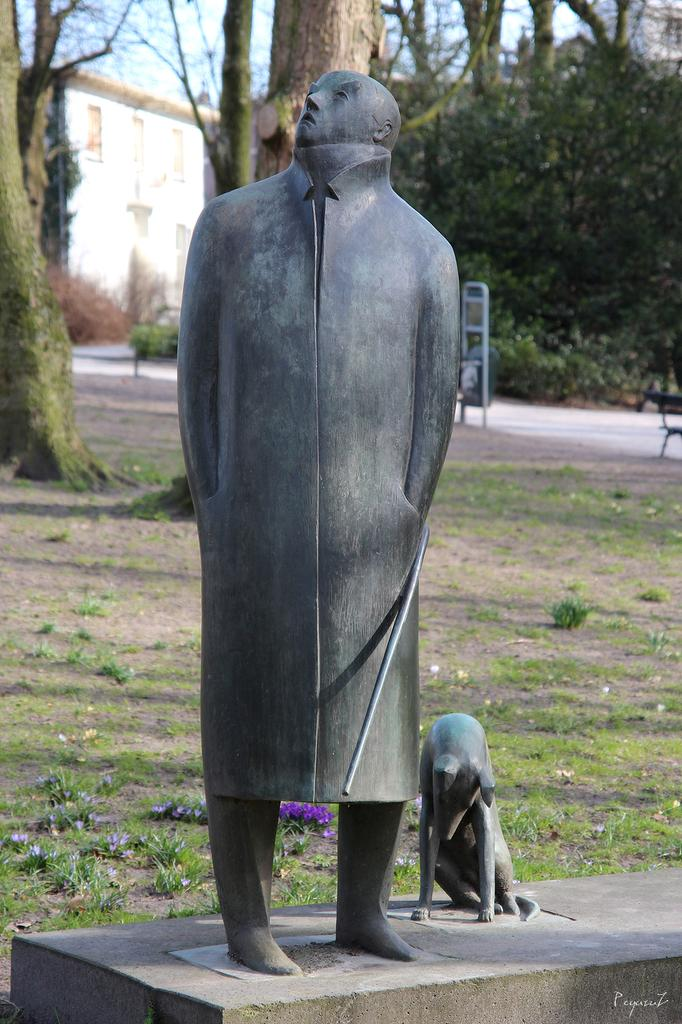What is the main subject in the center of the image? There is a statue in the center of the image. What can be seen in the background of the image? There are trees and a building in the background of the image. What type of ground is visible in the image? There is grass on the ground in the image. How many passengers are sitting on the cork in the image? There is no cork or passengers present in the image. 